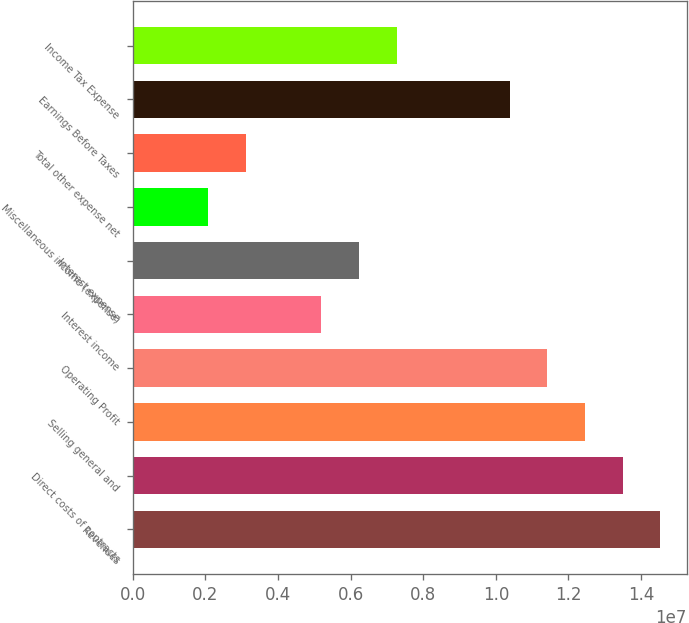Convert chart to OTSL. <chart><loc_0><loc_0><loc_500><loc_500><bar_chart><fcel>Revenues<fcel>Direct costs of contracts<fcel>Selling general and<fcel>Operating Profit<fcel>Interest income<fcel>Interest expense<fcel>Miscellaneous income (expense)<fcel>Total other expense net<fcel>Earnings Before Taxes<fcel>Income Tax Expense<nl><fcel>1.45343e+07<fcel>1.34962e+07<fcel>1.2458e+07<fcel>1.14198e+07<fcel>5.19083e+06<fcel>6.229e+06<fcel>2.07633e+06<fcel>3.1145e+06<fcel>1.03817e+07<fcel>7.26717e+06<nl></chart> 